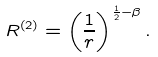Convert formula to latex. <formula><loc_0><loc_0><loc_500><loc_500>R ^ { \left ( 2 \right ) } = \left ( { \frac { 1 } { r } } \right ) ^ { \frac { 1 } { 2 } - \beta } .</formula> 